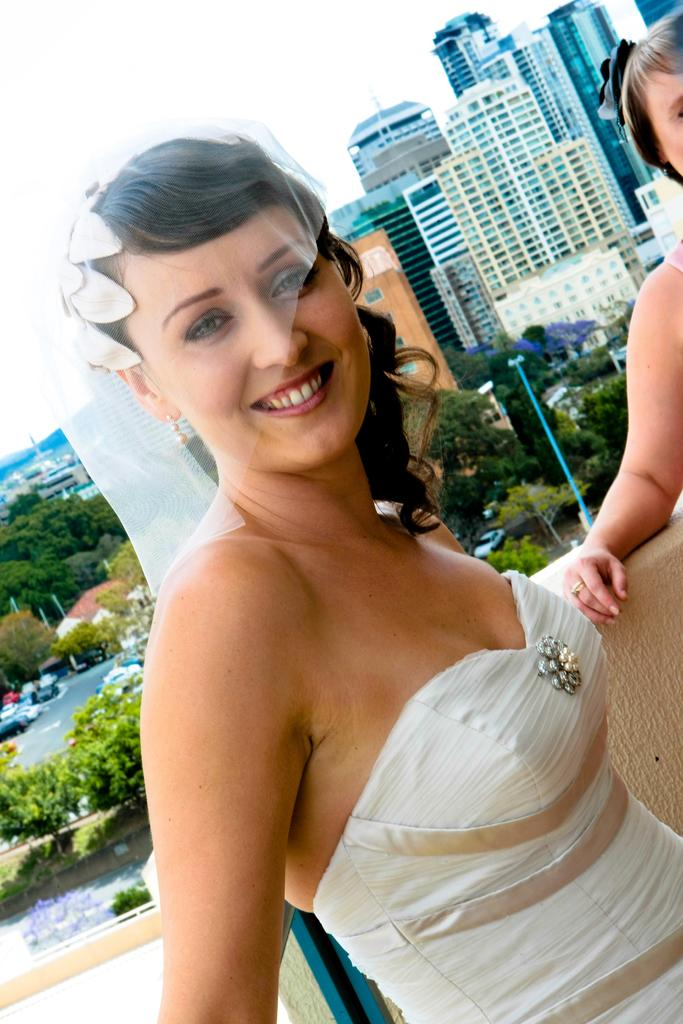What is the person in the foreground of the image wearing? The person in the foreground is wearing a white dress. What can be seen in the background of the image? The background of the image is white. What type of natural environment is visible in the image? There are many trees visible in the image. Can any structures be identified in the image? Yes, there is at least one building present in the image. What type of mask is the person wearing in the image? The person in the image is not wearing a mask; they are wearing a white dress. What type of canvas is visible in the image? There is no canvas present in the image. 